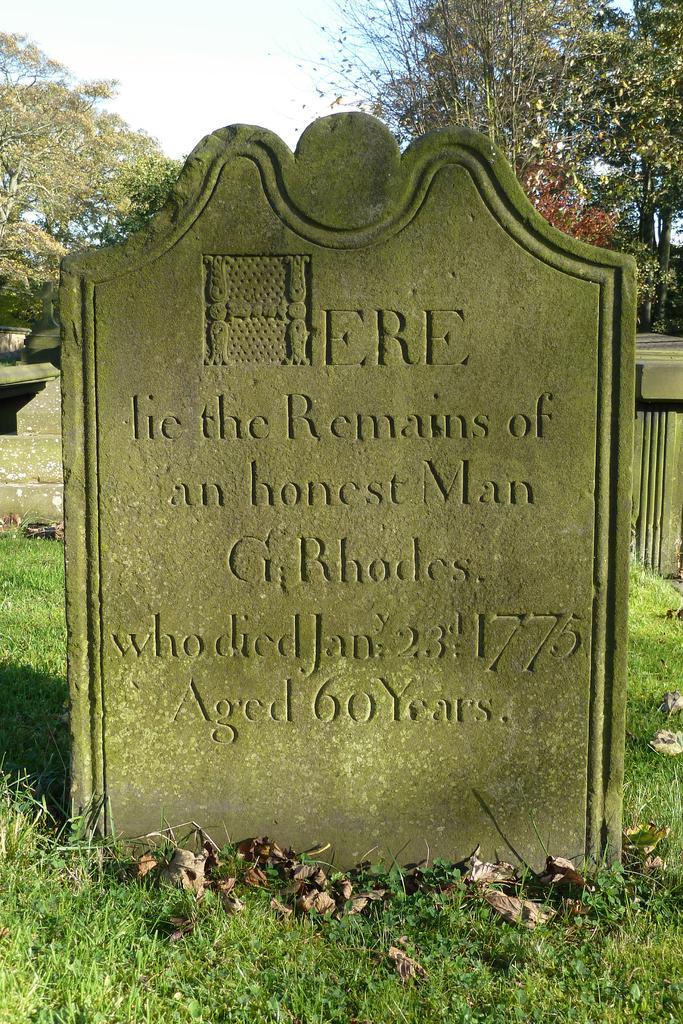Describe this image in one or two sentences. In this image we can see a graveyard. Behind trees are there. 